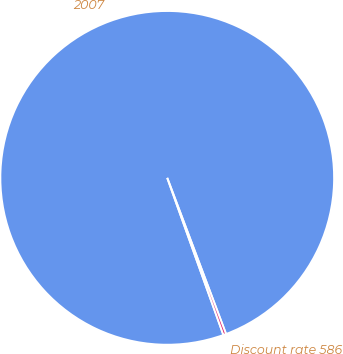<chart> <loc_0><loc_0><loc_500><loc_500><pie_chart><fcel>2007<fcel>Discount rate 586<nl><fcel>99.73%<fcel>0.27%<nl></chart> 